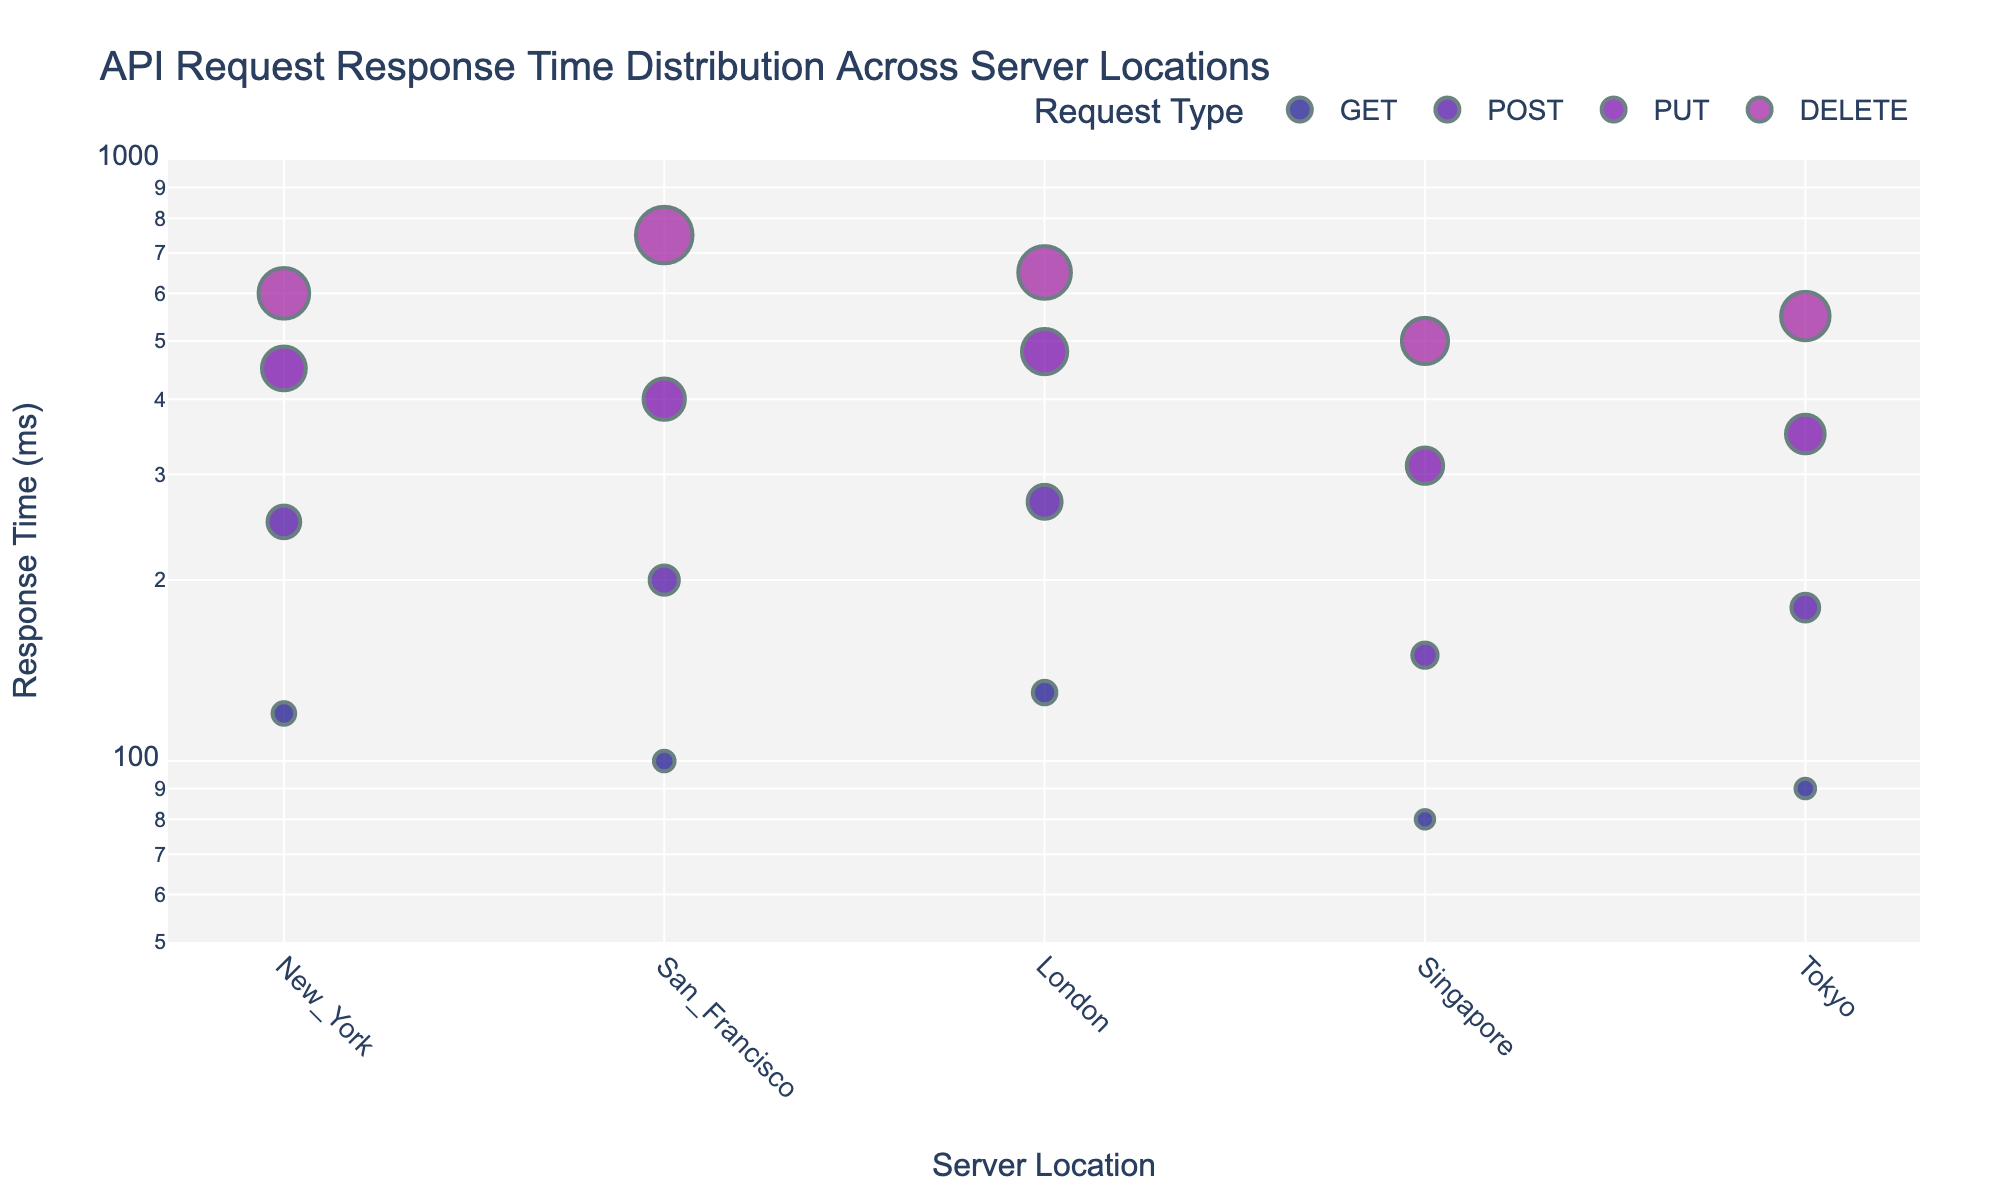What is the title of the plot? The title is usually located at the top of the plot. Look for the bold text which summarizes what the scatter plot is about.
Answer: API Request Response Time Distribution Across Server Locations Which server location has the lowest response time for GET requests? Identify the points corresponding to GET requests. Then, find the one with the smallest value on the y-axis in log scale, representing the lowest response time.
Answer: Singapore Which request type has the highest response time in San Francisco? Locate the data points for San Francisco on the x-axis. Find the point with the maximum y-axis value, which represents the highest response time.
Answer: DELETE How does the response time of POST requests compare between London and Tokyo? Identify the POST request points in London and Tokyo on the x-axis. Compare their y-axis values to see which is higher.
Answer: London has a higher response time for POST requests than Tokyo Which server location generally has the lowest response times across all request types? Determine the server location with the majority of its data points lower on the y-axis in the log scale, indicating lower response times.
Answer: Singapore What is the range of response times for PUT requests in New York? Identify the PUT request points in New York on the x-axis. Note the range of their y-values on the log scale for response times.
Answer: 450 ms Is there a significant difference in DELETE request response times between New York and Tokyo? Compare the DELETE request points in New York and Tokyo on the x-axis. Evaluate if their y-values, representing response times, differ greatly.
Answer: Yes, New York is higher than Tokyo What is the response time difference between the fastest and slowest server locations for POST requests? Locate the POST request points on the x-axis for all server locations. Subtract the smallest y-value from the largest y-value within these points.
Answer: 270 – 150 = 120 ms Which server location shows the most consistent response times across all request types? Look for the server location with data points closest together on the y-axis in the log scale, indicating less variation in response times.
Answer: Singapore What trend can be observed in response times as the request type changes from GET to DELETE across all server locations? Analyze the response time points for each request type. Note the general pattern of increase or decrease from GET to DELETE.
Answer: Response times generally increase from GET to DELETE 